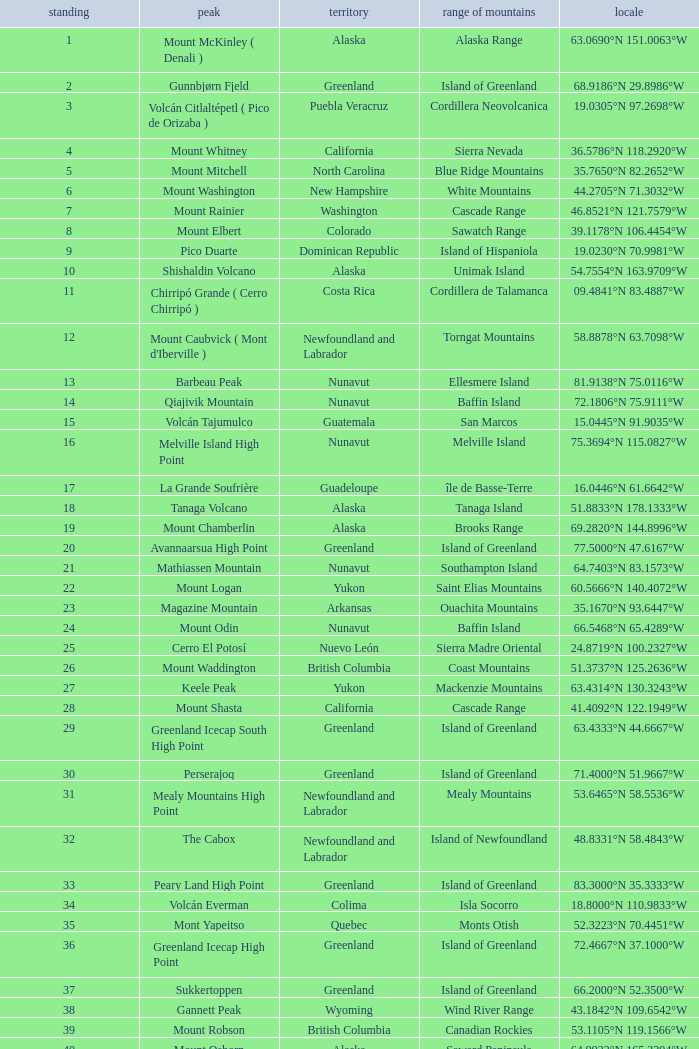Name the Mountain Peak which has a Rank of 62? Cerro Nube ( Quie Yelaag ). 